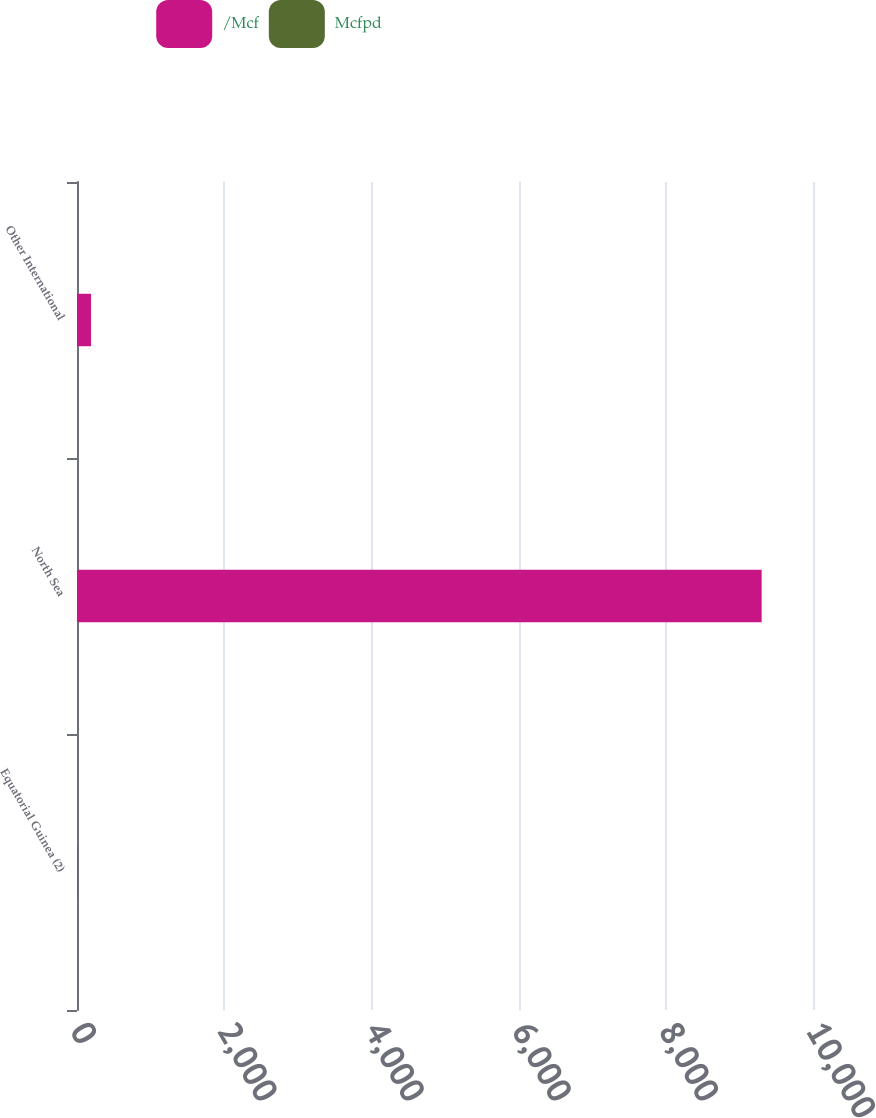Convert chart to OTSL. <chart><loc_0><loc_0><loc_500><loc_500><stacked_bar_chart><ecel><fcel>Equatorial Guinea (2)<fcel>North Sea<fcel>Other International<nl><fcel>/Mcf<fcel>5.93<fcel>9299<fcel>190<nl><fcel>Mcfpd<fcel>0.25<fcel>5.93<fcel>1.1<nl></chart> 